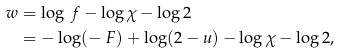<formula> <loc_0><loc_0><loc_500><loc_500>w & = \log \ f - \log \chi - \log 2 \\ & = - \log ( - \ F ) + \log ( 2 - u ) - \log \chi - \log 2 ,</formula> 